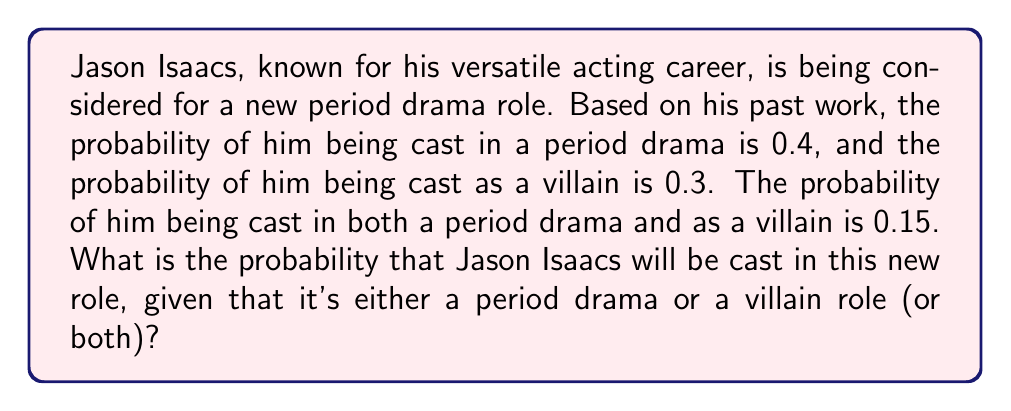Show me your answer to this math problem. Let's approach this step-by-step using probability theory:

1) Let's define our events:
   A = Being cast in a period drama
   B = Being cast as a villain

2) We're given:
   P(A) = 0.4
   P(B) = 0.3
   P(A ∩ B) = 0.15

3) We need to find P(A ∪ B), which is the probability of being cast in either a period drama or as a villain (or both).

4) We can use the addition rule of probability:
   P(A ∪ B) = P(A) + P(B) - P(A ∩ B)

5) Substituting the values:
   P(A ∪ B) = 0.4 + 0.3 - 0.15

6) Calculating:
   P(A ∪ B) = 0.55

Therefore, the probability that Jason Isaacs will be cast in this new role is 0.55 or 55%.
Answer: 0.55 